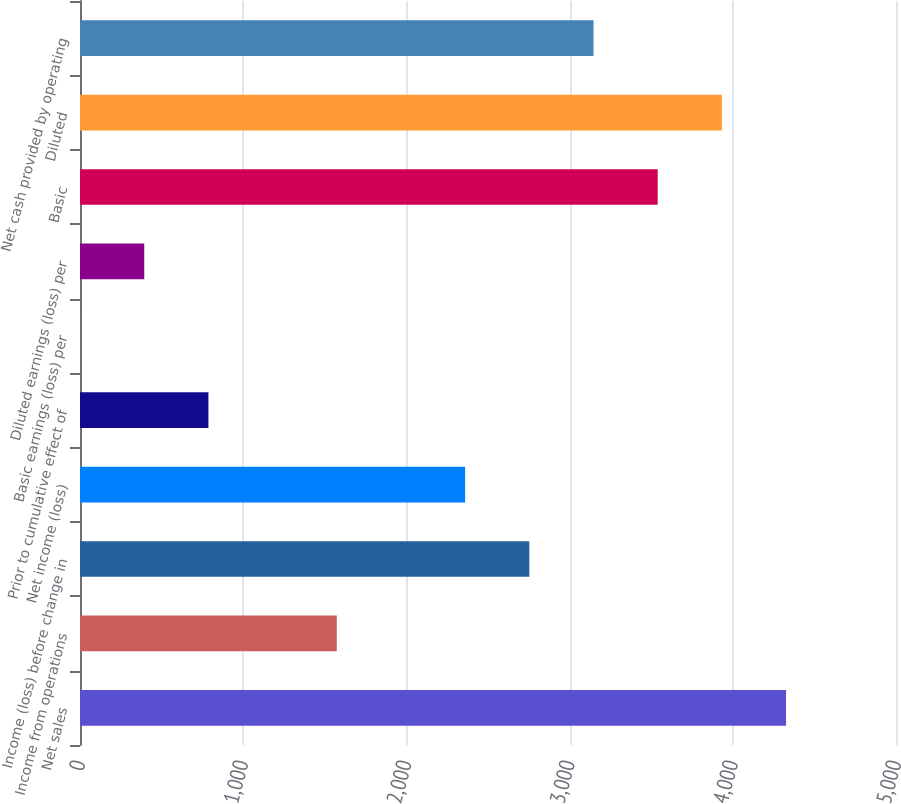Convert chart to OTSL. <chart><loc_0><loc_0><loc_500><loc_500><bar_chart><fcel>Net sales<fcel>Income from operations<fcel>Income (loss) before change in<fcel>Net income (loss)<fcel>Prior to cumulative effect of<fcel>Basic earnings (loss) per<fcel>Diluted earnings (loss) per<fcel>Basic<fcel>Diluted<fcel>Net cash provided by operating<nl><fcel>4326.25<fcel>1573.43<fcel>2753.21<fcel>2359.95<fcel>786.91<fcel>0.39<fcel>393.65<fcel>3539.73<fcel>3932.99<fcel>3146.47<nl></chart> 